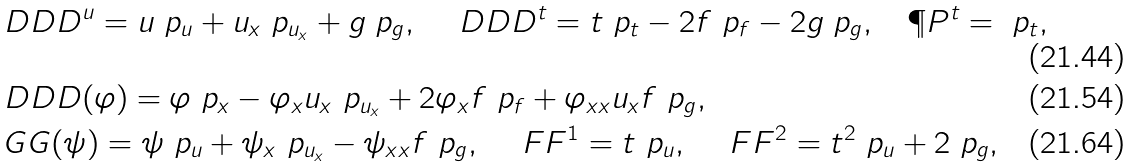Convert formula to latex. <formula><loc_0><loc_0><loc_500><loc_500>& \ D D D ^ { u } = u \ p _ { u } + u _ { x } \ p _ { u _ { x } } + g \ p _ { g } , \quad \ D D D ^ { t } = t \ p _ { t } - 2 f \ p _ { f } - 2 g \ p _ { g } , \quad \P P ^ { t } = \ p _ { t } , \\ & \ D D D ( \varphi ) = \varphi \ p _ { x } - \varphi _ { x } u _ { x } \ p _ { u _ { x } } + 2 \varphi _ { x } f \ p _ { f } + \varphi _ { x x } u _ { x } f \ p _ { g } , \\ & \ G G ( \psi ) = \psi \ p _ { u } + \psi _ { x } \ p _ { u _ { x } } - \psi _ { x x } f \ p _ { g } , \quad \ F F ^ { 1 } = t \ p _ { u } , \quad \ F F ^ { 2 } = t ^ { 2 } \ p _ { u } + 2 \ p _ { g } ,</formula> 